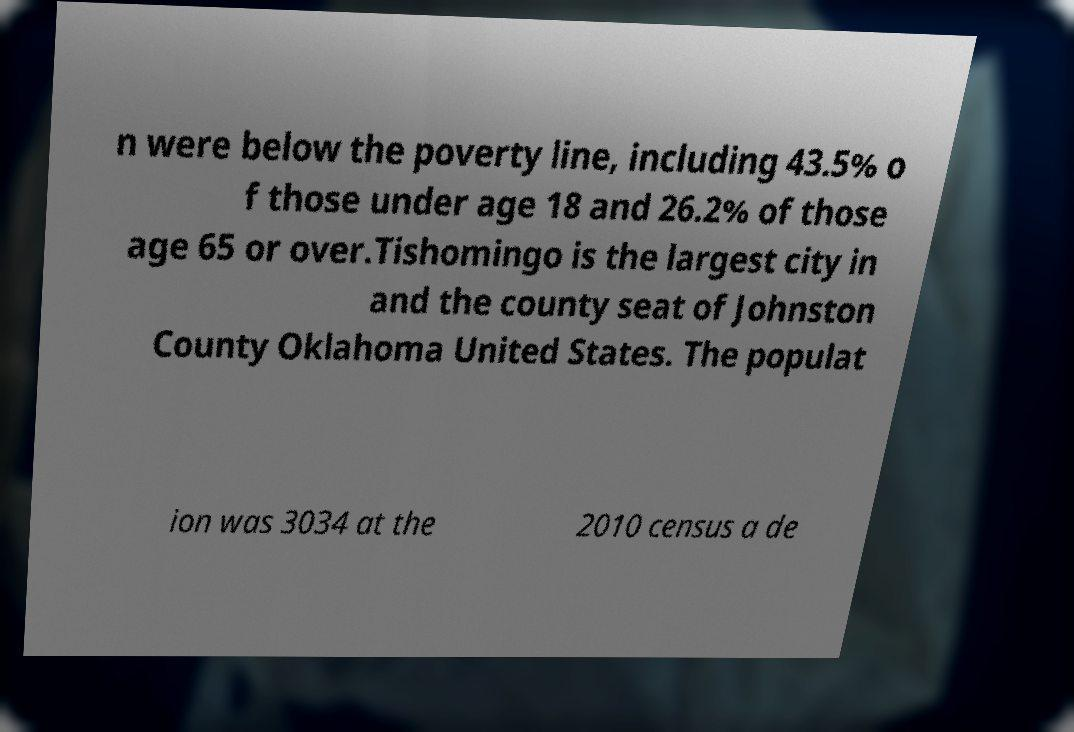Could you assist in decoding the text presented in this image and type it out clearly? n were below the poverty line, including 43.5% o f those under age 18 and 26.2% of those age 65 or over.Tishomingo is the largest city in and the county seat of Johnston County Oklahoma United States. The populat ion was 3034 at the 2010 census a de 